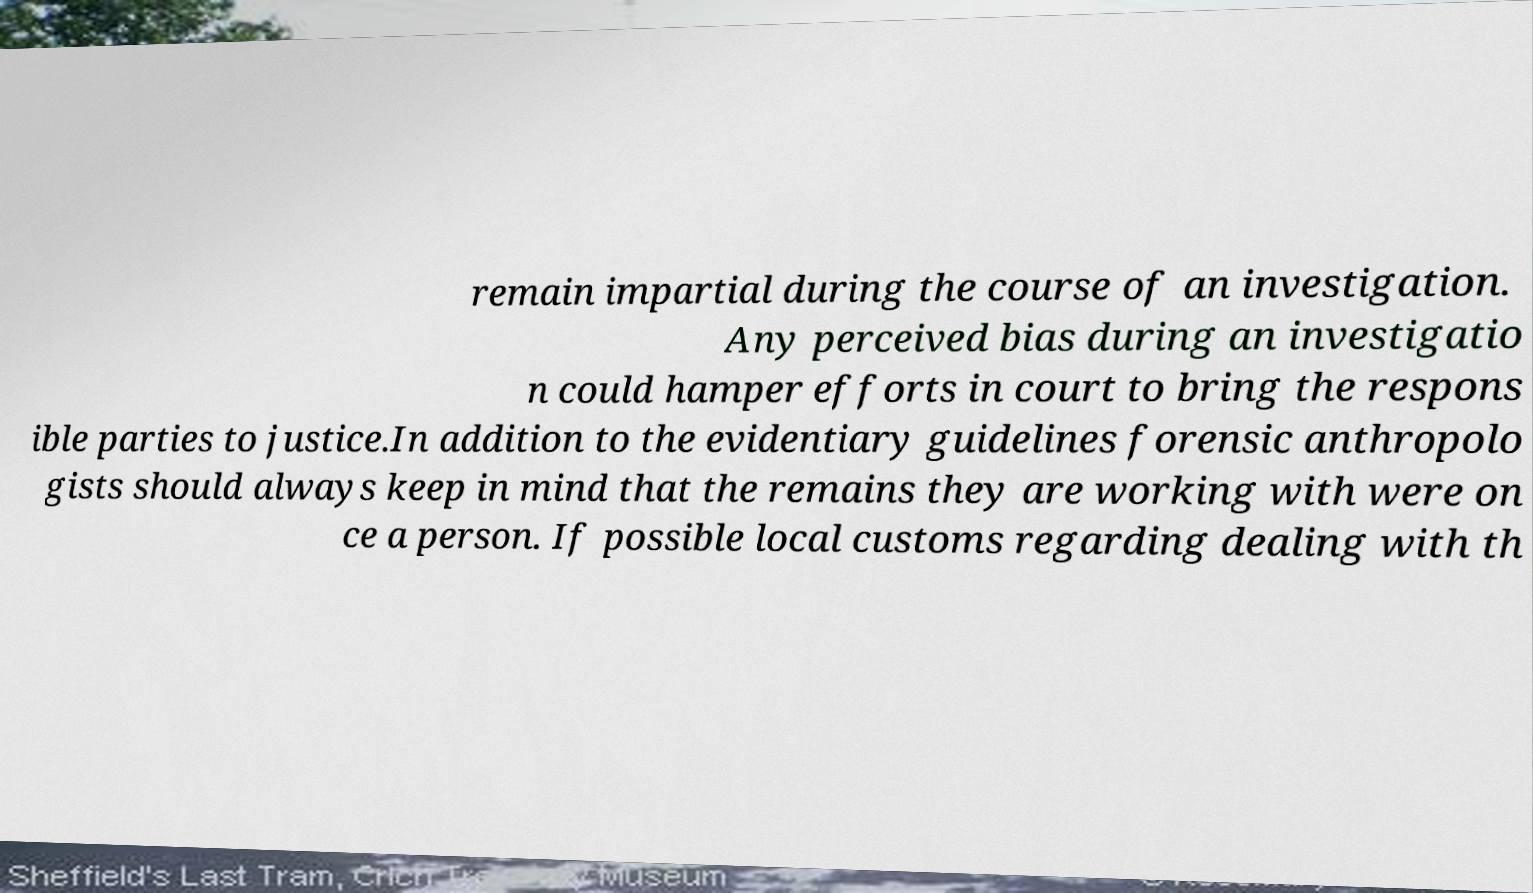Please identify and transcribe the text found in this image. remain impartial during the course of an investigation. Any perceived bias during an investigatio n could hamper efforts in court to bring the respons ible parties to justice.In addition to the evidentiary guidelines forensic anthropolo gists should always keep in mind that the remains they are working with were on ce a person. If possible local customs regarding dealing with th 